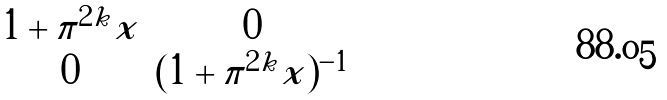<formula> <loc_0><loc_0><loc_500><loc_500>\begin{matrix} 1 + \pi ^ { 2 k } x & 0 \\ 0 & ( 1 + \pi ^ { 2 k } x ) ^ { - 1 } \end{matrix}</formula> 